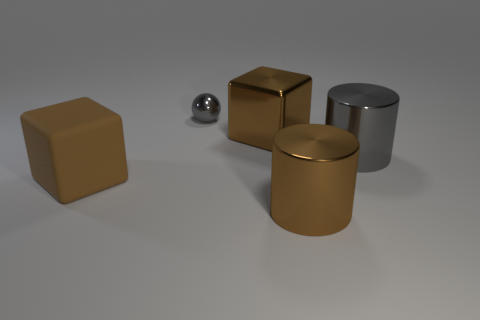Add 5 brown matte blocks. How many objects exist? 10 Subtract all cylinders. How many objects are left? 3 Add 3 big brown matte objects. How many big brown matte objects are left? 4 Add 2 gray metal balls. How many gray metal balls exist? 3 Subtract 1 brown cylinders. How many objects are left? 4 Subtract all small purple things. Subtract all gray metal spheres. How many objects are left? 4 